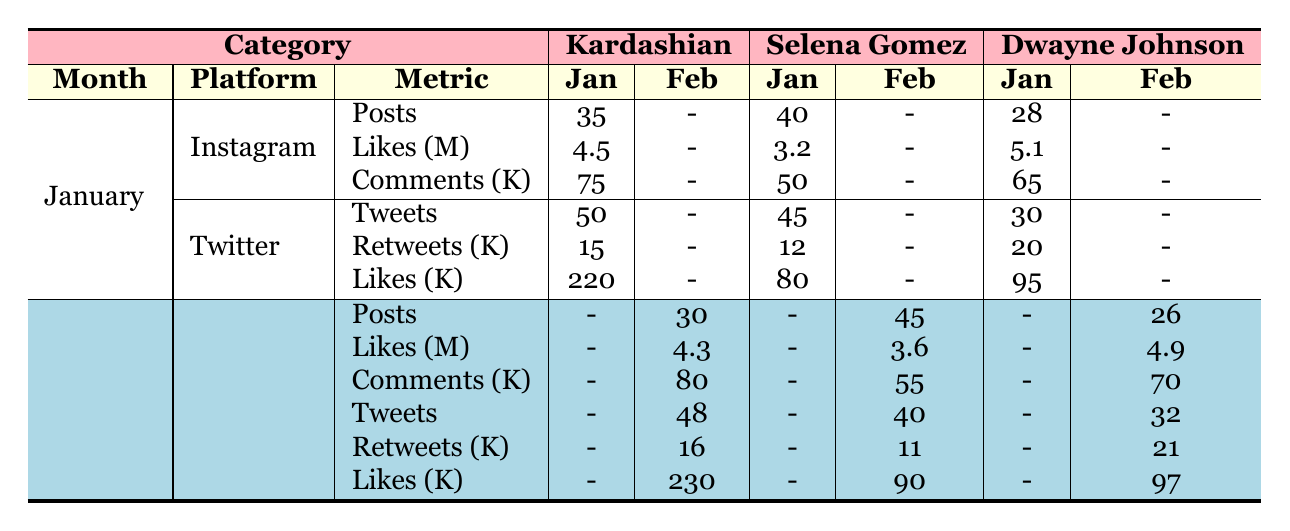What was the total number of tweets by the Kardashian in January? The table shows that the Kardashian tweeted 50 times in January on Twitter. Therefore, the total number of tweets is 50.
Answer: 50 Which celebrity had the most Instagram posts in February? According to the table, in February, Selena Gomez had 45 posts on Instagram, while Kardashian had 30 and Dwayne Johnson had 26 posts. Thus, Selena Gomez had the most posts.
Answer: Selena Gomez Was there an increase in likes on Instagram for Dwayne Johnson from January to February? In January, Dwayne Johnson received 5.1 million likes, and in February, he received 4.9 million likes on Instagram. Since 5.1 is greater than 4.9, this indicates a decrease in likes.
Answer: No How many more comments did Kardashian receive on Instagram in January compared to February? In January, Kardashian had 75 comments on Instagram and in February had 80 comments. The difference is 80 - 75 = 5. Thus, Kardashian actually received 5 more comments in February compared to January.
Answer: 5 What was the total engagement (likes, comments for Instagram and likes for Twitter) for Selena Gomez in January? For Selena Gomez in January, the engagement on Instagram was 3.2 million likes and 50,000 comments (0.05 million), and on Twitter, she had 80,000 likes. The total engagement calculation is 3.2 + 0.05 + 0.08 = 3.33 million.
Answer: 3.33 million Did Dwayne Johnson have more tweets than Selena Gomez in March? The table does not provide data for March, so we cannot compare the number of tweets for Dwayne Johnson and Selena Gomez in that month. Therefore, we cannot answer this question.
Answer: Unknown Which platform had the highest number of retweets for Kardashian in February? The table shows that in February, Kardashian had 16,000 retweets on Twitter and there is no data for retweets on Instagram. Therefore, Twitter had the highest number of retweets for Kardashian in February.
Answer: Twitter What was the average number of likes received by Dwayne Johnson across the two months? In January, Dwayne Johnson received 5.1 million likes and in February, he received 4.9 million likes, giving a total of 5.1 + 4.9 = 10 million. To find the average, divide by 2, yielding 10 million / 2 = 5 million.
Answer: 5 million 